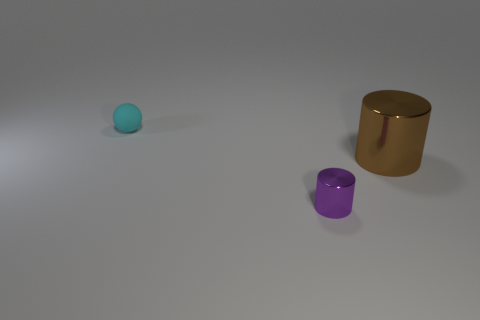Add 3 large brown things. How many objects exist? 6 Subtract all cylinders. How many objects are left? 1 Subtract all purple metallic cylinders. Subtract all large objects. How many objects are left? 1 Add 3 tiny cyan rubber balls. How many tiny cyan rubber balls are left? 4 Add 3 small rubber things. How many small rubber things exist? 4 Subtract 0 gray cubes. How many objects are left? 3 